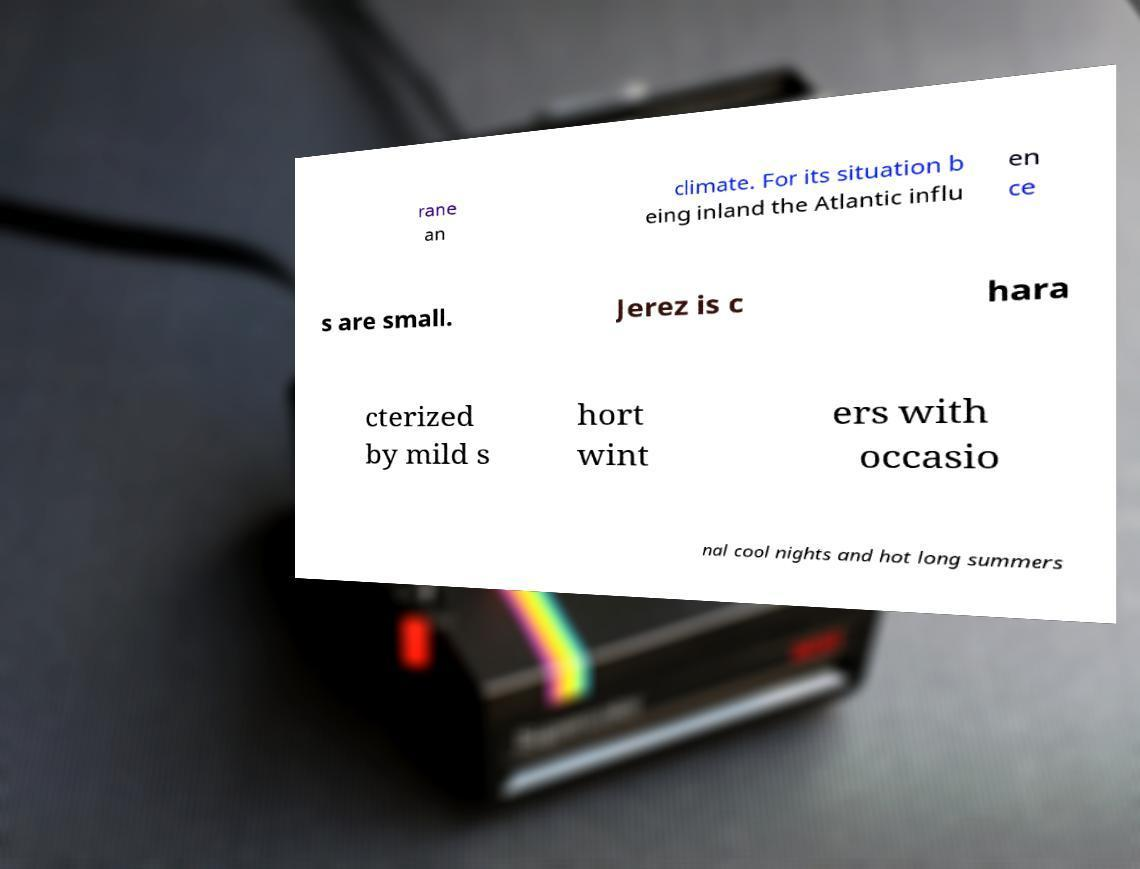There's text embedded in this image that I need extracted. Can you transcribe it verbatim? rane an climate. For its situation b eing inland the Atlantic influ en ce s are small. Jerez is c hara cterized by mild s hort wint ers with occasio nal cool nights and hot long summers 